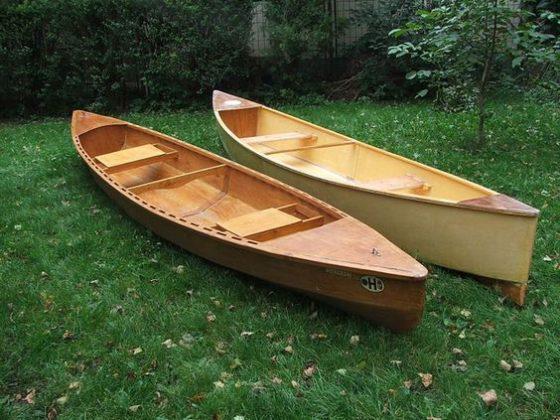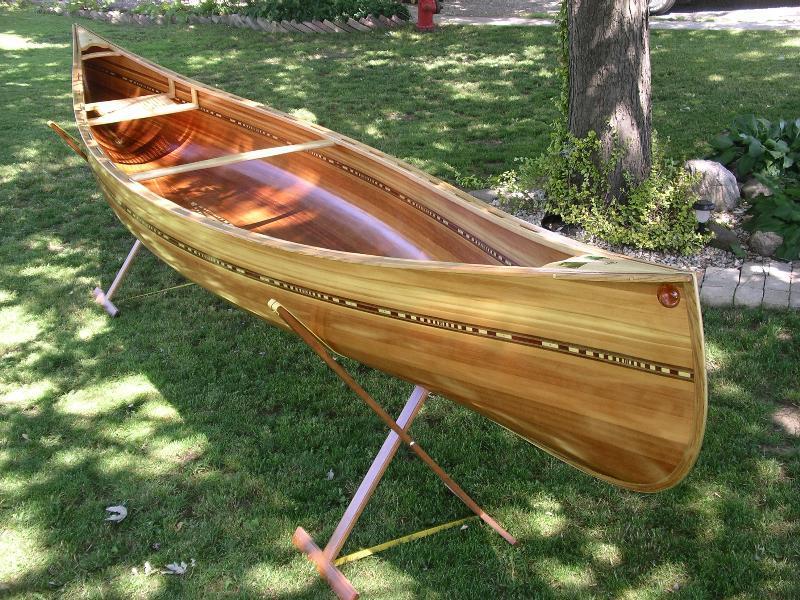The first image is the image on the left, the second image is the image on the right. Analyze the images presented: Is the assertion "One image shows side-by-side woodgrain canoes on land, and the other image includes a green canoe." valid? Answer yes or no. No. The first image is the image on the left, the second image is the image on the right. Analyze the images presented: Is the assertion "The left image contains two canoes laying next to each other in the grass." valid? Answer yes or no. Yes. 